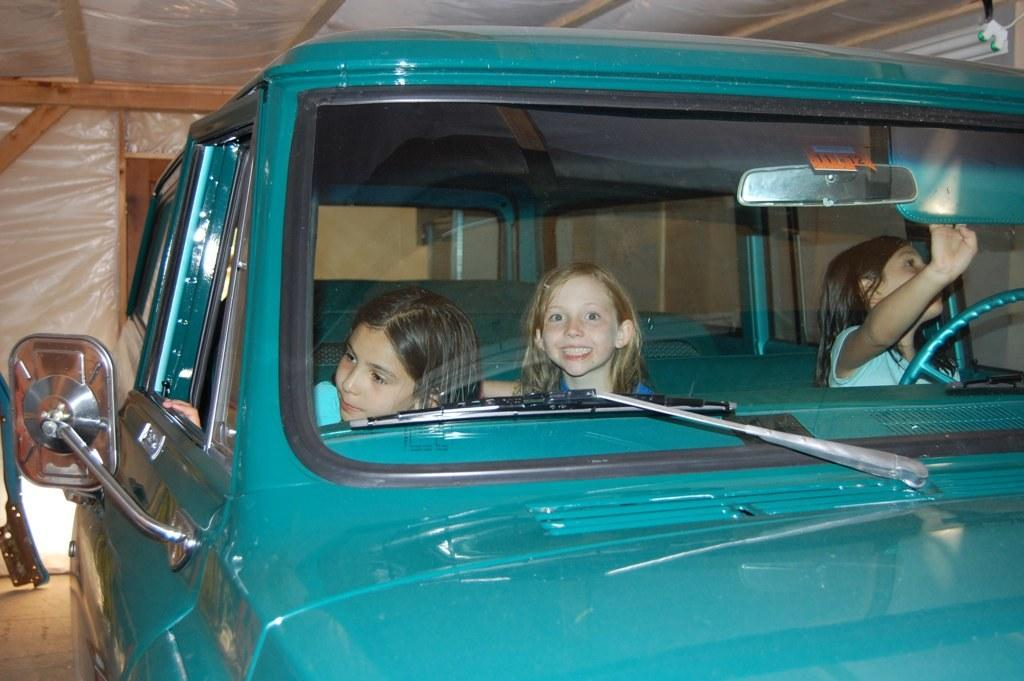What color is the car in the image? The car in the image is blue. How many kids are inside the car? There are three kids inside the car. What is the gender of the kids in the car? All three kids are girls. What can be seen in the background of the image? There is a wooden wall in the background of the image. What type of cakes are the girls rewarding the squirrel with in the image? There are no cakes or squirrels present in the image. 